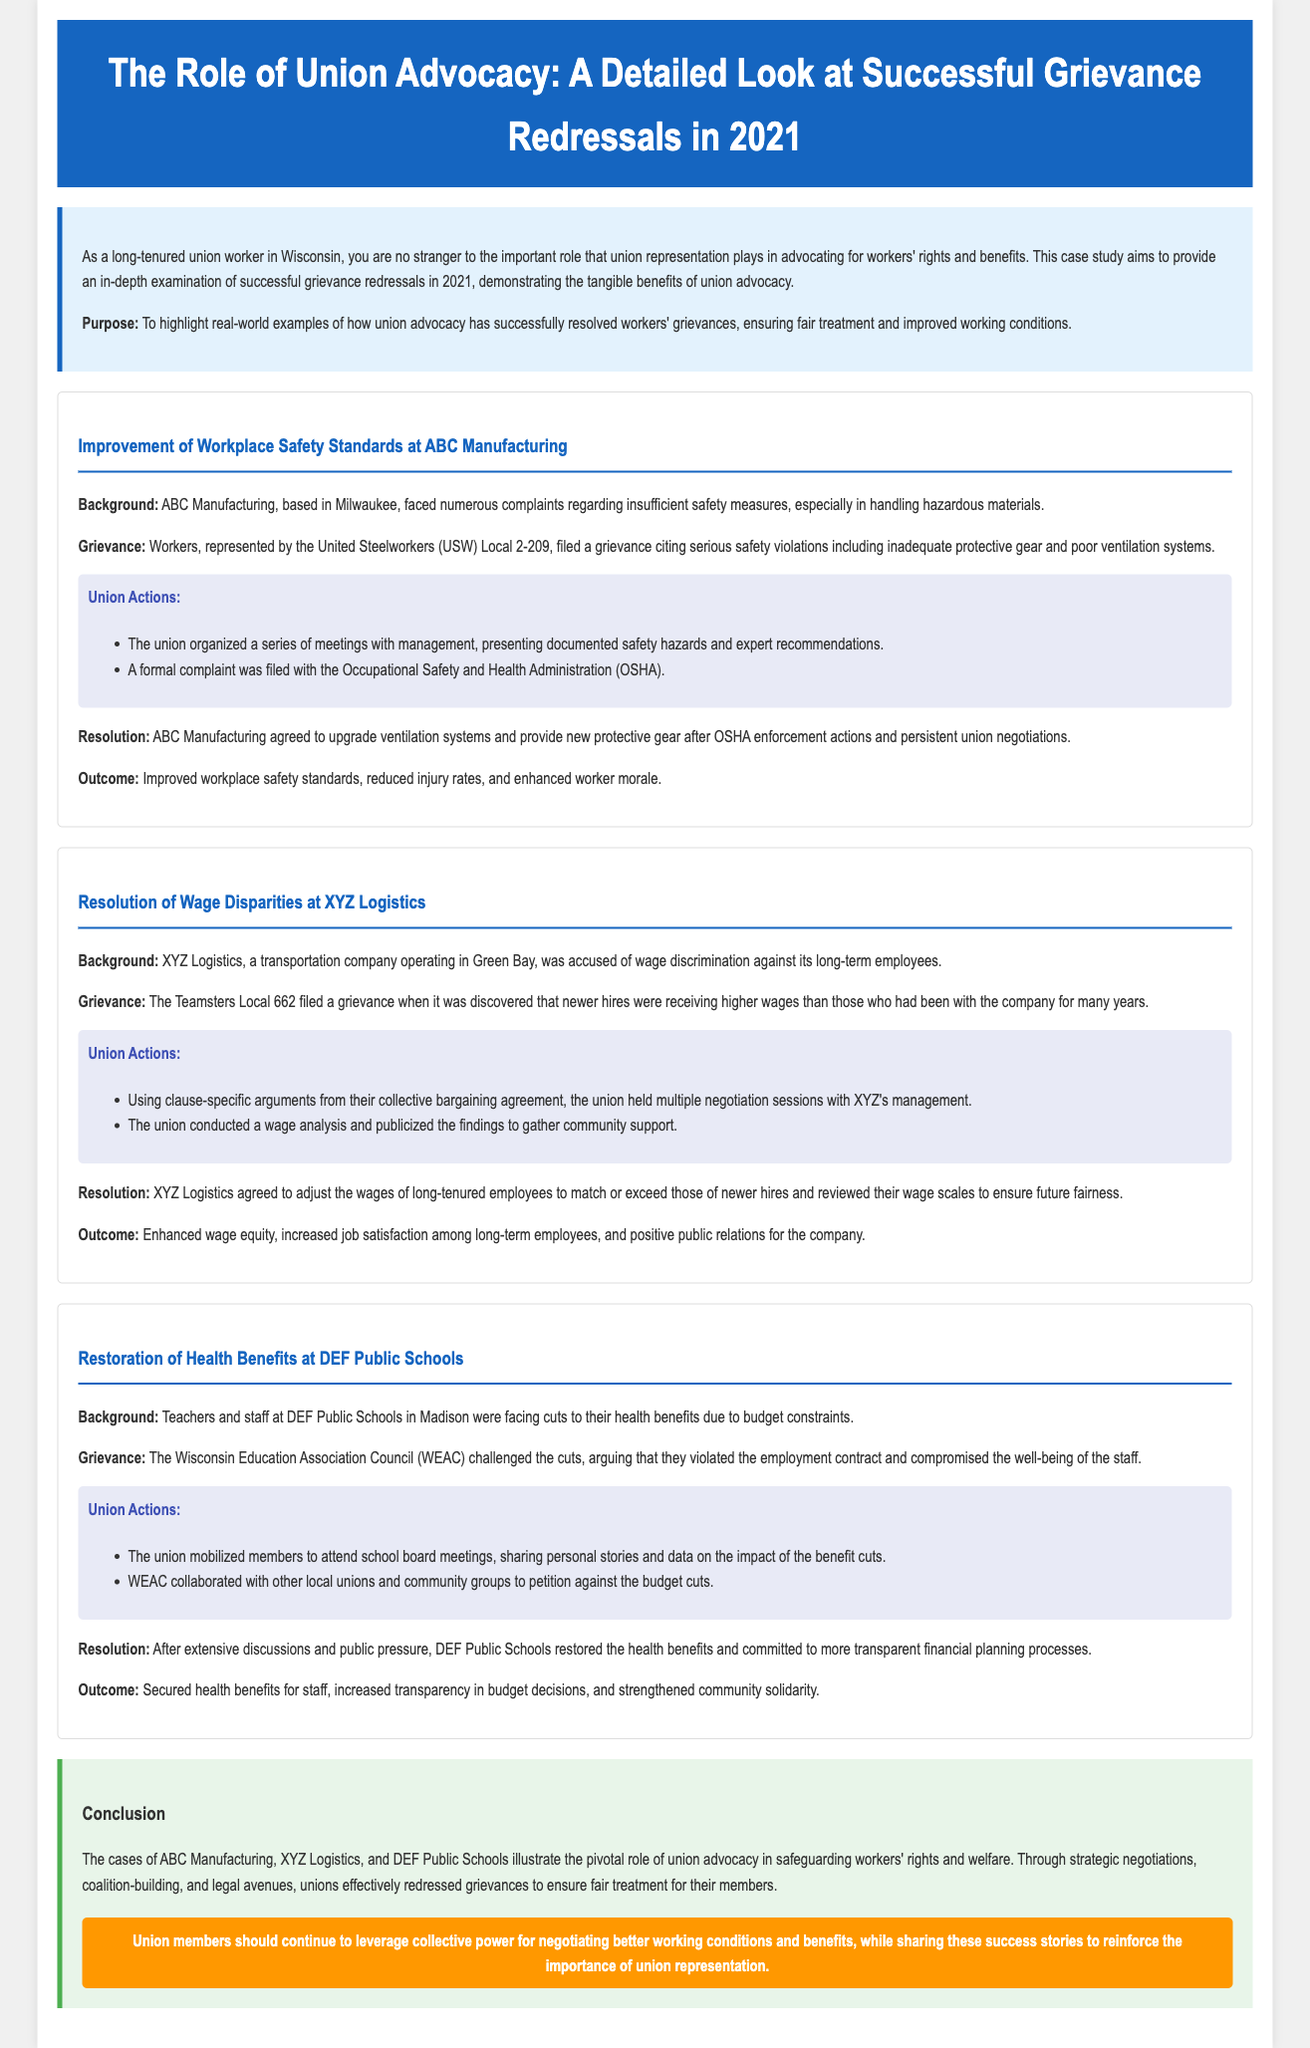What union represented workers at ABC Manufacturing? The union representing workers at ABC Manufacturing is the United Steelworkers (USW) Local 2-209.
Answer: United Steelworkers (USW) Local 2-209 What was the grievance at XYZ Logistics? The grievance at XYZ Logistics involved wage discrimination against long-term employees.
Answer: Wage discrimination What action did the union take regarding the complaint at ABC Manufacturing? The union filed a formal complaint with the Occupational Safety and Health Administration (OSHA) to address the safety violations.
Answer: Filed a formal complaint with OSHA What was the outcome for DEF Public Schools after the grievance? The outcome for DEF Public Schools was the restoration of health benefits for the staff.
Answer: Restoration of health benefits Which organization challenged the benefit cuts at DEF Public Schools? The Wisconsin Education Association Council (WEAC) challenged the benefit cuts.
Answer: Wisconsin Education Association Council (WEAC) What specific change did XYZ Logistics agree to implement? XYZ Logistics agreed to adjust the wages of long-tenured employees.
Answer: Adjust the wages of long-tenured employees What year does the case study focus on? The case study highlights successful grievance redressals specifically in the year 2021.
Answer: 2021 What was the central theme of the case studies presented? The central theme is the role of union advocacy in resolving grievances and improving working conditions.
Answer: Role of union advocacy What type of benefits were cut at DEF Public Schools? The benefits that were cut were health benefits for teachers and staff.
Answer: Health benefits 